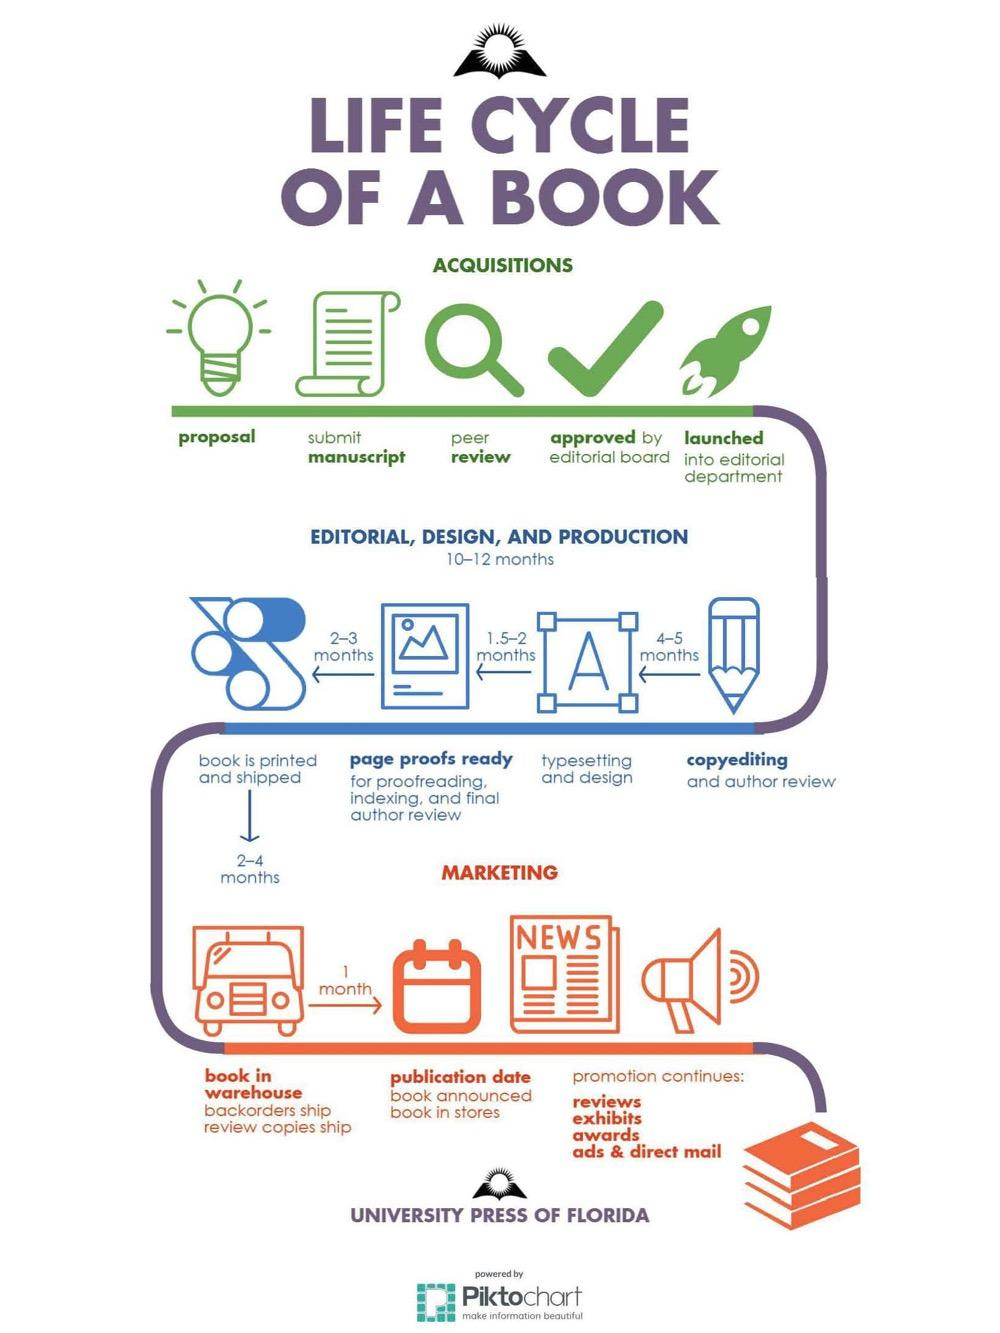Specify some key components in this picture. The third step in the acquisition process is peer review. The copyediting to typesetting and design process typically takes 4-5 months. 